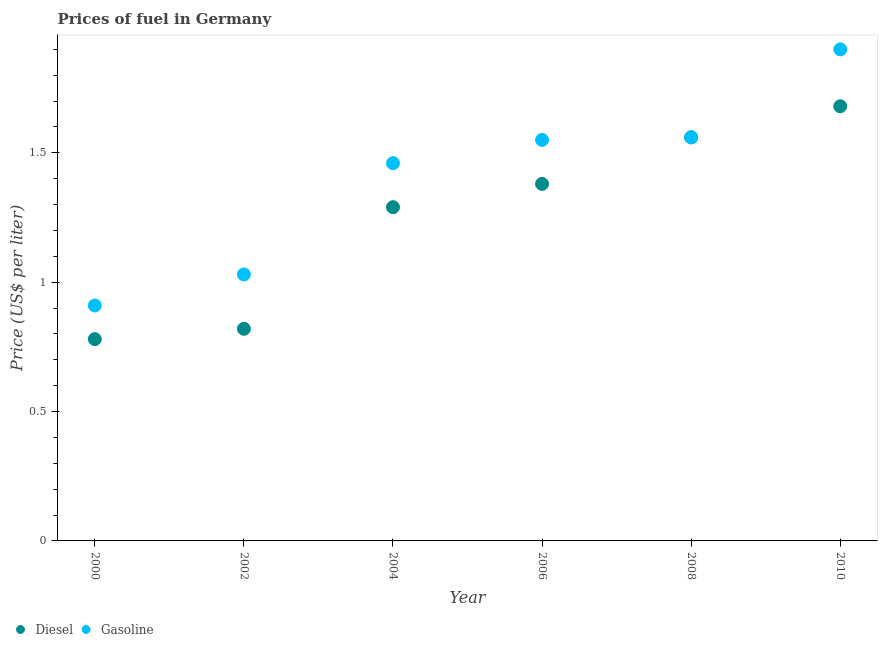How many different coloured dotlines are there?
Ensure brevity in your answer.  2. What is the diesel price in 2002?
Your answer should be very brief. 0.82. Across all years, what is the maximum diesel price?
Provide a succinct answer. 1.68. Across all years, what is the minimum diesel price?
Make the answer very short. 0.78. In which year was the diesel price maximum?
Keep it short and to the point. 2010. What is the total diesel price in the graph?
Keep it short and to the point. 7.51. What is the difference between the gasoline price in 2004 and that in 2010?
Ensure brevity in your answer.  -0.44. What is the difference between the diesel price in 2006 and the gasoline price in 2000?
Offer a very short reply. 0.47. What is the average gasoline price per year?
Your response must be concise. 1.4. In the year 2002, what is the difference between the diesel price and gasoline price?
Give a very brief answer. -0.21. In how many years, is the gasoline price greater than 1.4 US$ per litre?
Keep it short and to the point. 4. What is the ratio of the diesel price in 2006 to that in 2010?
Your response must be concise. 0.82. Is the diesel price in 2004 less than that in 2006?
Keep it short and to the point. Yes. Is the difference between the diesel price in 2002 and 2010 greater than the difference between the gasoline price in 2002 and 2010?
Offer a terse response. Yes. What is the difference between the highest and the second highest diesel price?
Provide a short and direct response. 0.12. What is the difference between the highest and the lowest diesel price?
Make the answer very short. 0.9. Is the sum of the diesel price in 2002 and 2008 greater than the maximum gasoline price across all years?
Give a very brief answer. Yes. Does the gasoline price monotonically increase over the years?
Make the answer very short. Yes. Is the diesel price strictly less than the gasoline price over the years?
Make the answer very short. No. How many dotlines are there?
Your answer should be compact. 2. What is the difference between two consecutive major ticks on the Y-axis?
Your answer should be very brief. 0.5. Are the values on the major ticks of Y-axis written in scientific E-notation?
Keep it short and to the point. No. Does the graph contain any zero values?
Make the answer very short. No. What is the title of the graph?
Give a very brief answer. Prices of fuel in Germany. What is the label or title of the Y-axis?
Give a very brief answer. Price (US$ per liter). What is the Price (US$ per liter) in Diesel in 2000?
Provide a short and direct response. 0.78. What is the Price (US$ per liter) of Gasoline in 2000?
Your answer should be very brief. 0.91. What is the Price (US$ per liter) of Diesel in 2002?
Offer a terse response. 0.82. What is the Price (US$ per liter) in Gasoline in 2002?
Keep it short and to the point. 1.03. What is the Price (US$ per liter) of Diesel in 2004?
Keep it short and to the point. 1.29. What is the Price (US$ per liter) in Gasoline in 2004?
Ensure brevity in your answer.  1.46. What is the Price (US$ per liter) in Diesel in 2006?
Give a very brief answer. 1.38. What is the Price (US$ per liter) in Gasoline in 2006?
Give a very brief answer. 1.55. What is the Price (US$ per liter) of Diesel in 2008?
Provide a succinct answer. 1.56. What is the Price (US$ per liter) in Gasoline in 2008?
Keep it short and to the point. 1.56. What is the Price (US$ per liter) in Diesel in 2010?
Your answer should be compact. 1.68. What is the Price (US$ per liter) in Gasoline in 2010?
Keep it short and to the point. 1.9. Across all years, what is the maximum Price (US$ per liter) in Diesel?
Keep it short and to the point. 1.68. Across all years, what is the maximum Price (US$ per liter) in Gasoline?
Keep it short and to the point. 1.9. Across all years, what is the minimum Price (US$ per liter) in Diesel?
Provide a short and direct response. 0.78. Across all years, what is the minimum Price (US$ per liter) in Gasoline?
Keep it short and to the point. 0.91. What is the total Price (US$ per liter) of Diesel in the graph?
Provide a succinct answer. 7.51. What is the total Price (US$ per liter) of Gasoline in the graph?
Provide a succinct answer. 8.41. What is the difference between the Price (US$ per liter) of Diesel in 2000 and that in 2002?
Your answer should be compact. -0.04. What is the difference between the Price (US$ per liter) of Gasoline in 2000 and that in 2002?
Ensure brevity in your answer.  -0.12. What is the difference between the Price (US$ per liter) of Diesel in 2000 and that in 2004?
Your response must be concise. -0.51. What is the difference between the Price (US$ per liter) in Gasoline in 2000 and that in 2004?
Your answer should be compact. -0.55. What is the difference between the Price (US$ per liter) in Diesel in 2000 and that in 2006?
Provide a short and direct response. -0.6. What is the difference between the Price (US$ per liter) of Gasoline in 2000 and that in 2006?
Your answer should be very brief. -0.64. What is the difference between the Price (US$ per liter) of Diesel in 2000 and that in 2008?
Give a very brief answer. -0.78. What is the difference between the Price (US$ per liter) of Gasoline in 2000 and that in 2008?
Give a very brief answer. -0.65. What is the difference between the Price (US$ per liter) in Diesel in 2000 and that in 2010?
Ensure brevity in your answer.  -0.9. What is the difference between the Price (US$ per liter) in Gasoline in 2000 and that in 2010?
Offer a terse response. -0.99. What is the difference between the Price (US$ per liter) in Diesel in 2002 and that in 2004?
Your answer should be compact. -0.47. What is the difference between the Price (US$ per liter) in Gasoline in 2002 and that in 2004?
Make the answer very short. -0.43. What is the difference between the Price (US$ per liter) of Diesel in 2002 and that in 2006?
Your response must be concise. -0.56. What is the difference between the Price (US$ per liter) in Gasoline in 2002 and that in 2006?
Your answer should be very brief. -0.52. What is the difference between the Price (US$ per liter) of Diesel in 2002 and that in 2008?
Make the answer very short. -0.74. What is the difference between the Price (US$ per liter) in Gasoline in 2002 and that in 2008?
Ensure brevity in your answer.  -0.53. What is the difference between the Price (US$ per liter) in Diesel in 2002 and that in 2010?
Your answer should be very brief. -0.86. What is the difference between the Price (US$ per liter) of Gasoline in 2002 and that in 2010?
Offer a very short reply. -0.87. What is the difference between the Price (US$ per liter) in Diesel in 2004 and that in 2006?
Your answer should be very brief. -0.09. What is the difference between the Price (US$ per liter) of Gasoline in 2004 and that in 2006?
Provide a short and direct response. -0.09. What is the difference between the Price (US$ per liter) of Diesel in 2004 and that in 2008?
Offer a very short reply. -0.27. What is the difference between the Price (US$ per liter) in Diesel in 2004 and that in 2010?
Give a very brief answer. -0.39. What is the difference between the Price (US$ per liter) in Gasoline in 2004 and that in 2010?
Make the answer very short. -0.44. What is the difference between the Price (US$ per liter) in Diesel in 2006 and that in 2008?
Provide a succinct answer. -0.18. What is the difference between the Price (US$ per liter) in Gasoline in 2006 and that in 2008?
Ensure brevity in your answer.  -0.01. What is the difference between the Price (US$ per liter) in Diesel in 2006 and that in 2010?
Offer a very short reply. -0.3. What is the difference between the Price (US$ per liter) of Gasoline in 2006 and that in 2010?
Keep it short and to the point. -0.35. What is the difference between the Price (US$ per liter) in Diesel in 2008 and that in 2010?
Make the answer very short. -0.12. What is the difference between the Price (US$ per liter) of Gasoline in 2008 and that in 2010?
Your answer should be compact. -0.34. What is the difference between the Price (US$ per liter) in Diesel in 2000 and the Price (US$ per liter) in Gasoline in 2002?
Make the answer very short. -0.25. What is the difference between the Price (US$ per liter) of Diesel in 2000 and the Price (US$ per liter) of Gasoline in 2004?
Make the answer very short. -0.68. What is the difference between the Price (US$ per liter) of Diesel in 2000 and the Price (US$ per liter) of Gasoline in 2006?
Keep it short and to the point. -0.77. What is the difference between the Price (US$ per liter) in Diesel in 2000 and the Price (US$ per liter) in Gasoline in 2008?
Your answer should be very brief. -0.78. What is the difference between the Price (US$ per liter) of Diesel in 2000 and the Price (US$ per liter) of Gasoline in 2010?
Give a very brief answer. -1.12. What is the difference between the Price (US$ per liter) in Diesel in 2002 and the Price (US$ per liter) in Gasoline in 2004?
Your answer should be compact. -0.64. What is the difference between the Price (US$ per liter) of Diesel in 2002 and the Price (US$ per liter) of Gasoline in 2006?
Your answer should be very brief. -0.73. What is the difference between the Price (US$ per liter) in Diesel in 2002 and the Price (US$ per liter) in Gasoline in 2008?
Give a very brief answer. -0.74. What is the difference between the Price (US$ per liter) of Diesel in 2002 and the Price (US$ per liter) of Gasoline in 2010?
Offer a very short reply. -1.08. What is the difference between the Price (US$ per liter) in Diesel in 2004 and the Price (US$ per liter) in Gasoline in 2006?
Give a very brief answer. -0.26. What is the difference between the Price (US$ per liter) of Diesel in 2004 and the Price (US$ per liter) of Gasoline in 2008?
Provide a succinct answer. -0.27. What is the difference between the Price (US$ per liter) of Diesel in 2004 and the Price (US$ per liter) of Gasoline in 2010?
Keep it short and to the point. -0.61. What is the difference between the Price (US$ per liter) of Diesel in 2006 and the Price (US$ per liter) of Gasoline in 2008?
Make the answer very short. -0.18. What is the difference between the Price (US$ per liter) in Diesel in 2006 and the Price (US$ per liter) in Gasoline in 2010?
Your response must be concise. -0.52. What is the difference between the Price (US$ per liter) of Diesel in 2008 and the Price (US$ per liter) of Gasoline in 2010?
Provide a short and direct response. -0.34. What is the average Price (US$ per liter) of Diesel per year?
Provide a short and direct response. 1.25. What is the average Price (US$ per liter) of Gasoline per year?
Your answer should be compact. 1.4. In the year 2000, what is the difference between the Price (US$ per liter) of Diesel and Price (US$ per liter) of Gasoline?
Offer a very short reply. -0.13. In the year 2002, what is the difference between the Price (US$ per liter) of Diesel and Price (US$ per liter) of Gasoline?
Your answer should be very brief. -0.21. In the year 2004, what is the difference between the Price (US$ per liter) in Diesel and Price (US$ per liter) in Gasoline?
Your answer should be compact. -0.17. In the year 2006, what is the difference between the Price (US$ per liter) of Diesel and Price (US$ per liter) of Gasoline?
Make the answer very short. -0.17. In the year 2008, what is the difference between the Price (US$ per liter) of Diesel and Price (US$ per liter) of Gasoline?
Keep it short and to the point. 0. In the year 2010, what is the difference between the Price (US$ per liter) of Diesel and Price (US$ per liter) of Gasoline?
Offer a terse response. -0.22. What is the ratio of the Price (US$ per liter) of Diesel in 2000 to that in 2002?
Ensure brevity in your answer.  0.95. What is the ratio of the Price (US$ per liter) of Gasoline in 2000 to that in 2002?
Provide a short and direct response. 0.88. What is the ratio of the Price (US$ per liter) of Diesel in 2000 to that in 2004?
Offer a very short reply. 0.6. What is the ratio of the Price (US$ per liter) of Gasoline in 2000 to that in 2004?
Offer a terse response. 0.62. What is the ratio of the Price (US$ per liter) of Diesel in 2000 to that in 2006?
Provide a short and direct response. 0.57. What is the ratio of the Price (US$ per liter) in Gasoline in 2000 to that in 2006?
Ensure brevity in your answer.  0.59. What is the ratio of the Price (US$ per liter) in Diesel in 2000 to that in 2008?
Provide a short and direct response. 0.5. What is the ratio of the Price (US$ per liter) of Gasoline in 2000 to that in 2008?
Ensure brevity in your answer.  0.58. What is the ratio of the Price (US$ per liter) in Diesel in 2000 to that in 2010?
Provide a succinct answer. 0.46. What is the ratio of the Price (US$ per liter) of Gasoline in 2000 to that in 2010?
Offer a very short reply. 0.48. What is the ratio of the Price (US$ per liter) in Diesel in 2002 to that in 2004?
Your answer should be compact. 0.64. What is the ratio of the Price (US$ per liter) in Gasoline in 2002 to that in 2004?
Give a very brief answer. 0.71. What is the ratio of the Price (US$ per liter) of Diesel in 2002 to that in 2006?
Your response must be concise. 0.59. What is the ratio of the Price (US$ per liter) in Gasoline in 2002 to that in 2006?
Make the answer very short. 0.66. What is the ratio of the Price (US$ per liter) in Diesel in 2002 to that in 2008?
Your answer should be very brief. 0.53. What is the ratio of the Price (US$ per liter) in Gasoline in 2002 to that in 2008?
Offer a very short reply. 0.66. What is the ratio of the Price (US$ per liter) in Diesel in 2002 to that in 2010?
Make the answer very short. 0.49. What is the ratio of the Price (US$ per liter) in Gasoline in 2002 to that in 2010?
Provide a short and direct response. 0.54. What is the ratio of the Price (US$ per liter) of Diesel in 2004 to that in 2006?
Offer a terse response. 0.93. What is the ratio of the Price (US$ per liter) in Gasoline in 2004 to that in 2006?
Keep it short and to the point. 0.94. What is the ratio of the Price (US$ per liter) of Diesel in 2004 to that in 2008?
Offer a very short reply. 0.83. What is the ratio of the Price (US$ per liter) in Gasoline in 2004 to that in 2008?
Your answer should be very brief. 0.94. What is the ratio of the Price (US$ per liter) of Diesel in 2004 to that in 2010?
Your response must be concise. 0.77. What is the ratio of the Price (US$ per liter) in Gasoline in 2004 to that in 2010?
Your answer should be very brief. 0.77. What is the ratio of the Price (US$ per liter) of Diesel in 2006 to that in 2008?
Give a very brief answer. 0.88. What is the ratio of the Price (US$ per liter) of Gasoline in 2006 to that in 2008?
Your response must be concise. 0.99. What is the ratio of the Price (US$ per liter) in Diesel in 2006 to that in 2010?
Keep it short and to the point. 0.82. What is the ratio of the Price (US$ per liter) in Gasoline in 2006 to that in 2010?
Your answer should be compact. 0.82. What is the ratio of the Price (US$ per liter) of Diesel in 2008 to that in 2010?
Provide a short and direct response. 0.93. What is the ratio of the Price (US$ per liter) in Gasoline in 2008 to that in 2010?
Make the answer very short. 0.82. What is the difference between the highest and the second highest Price (US$ per liter) in Diesel?
Give a very brief answer. 0.12. What is the difference between the highest and the second highest Price (US$ per liter) of Gasoline?
Ensure brevity in your answer.  0.34. What is the difference between the highest and the lowest Price (US$ per liter) of Gasoline?
Your response must be concise. 0.99. 